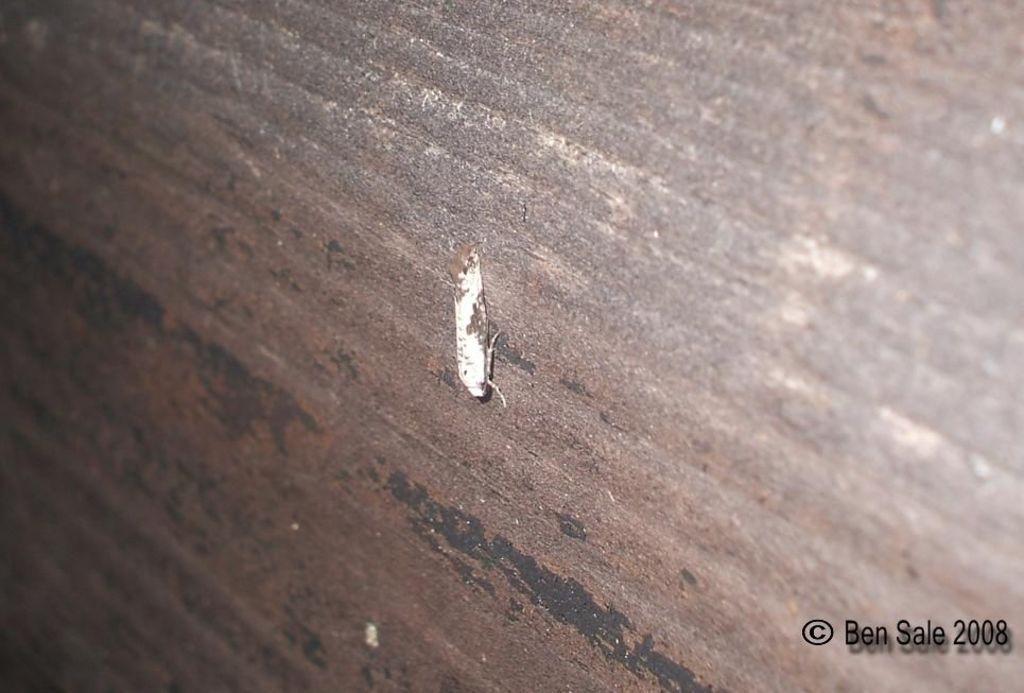Could you give a brief overview of what you see in this image? In this image, we can see an insect on the surface. We can also see some text on the bottom right corner. 